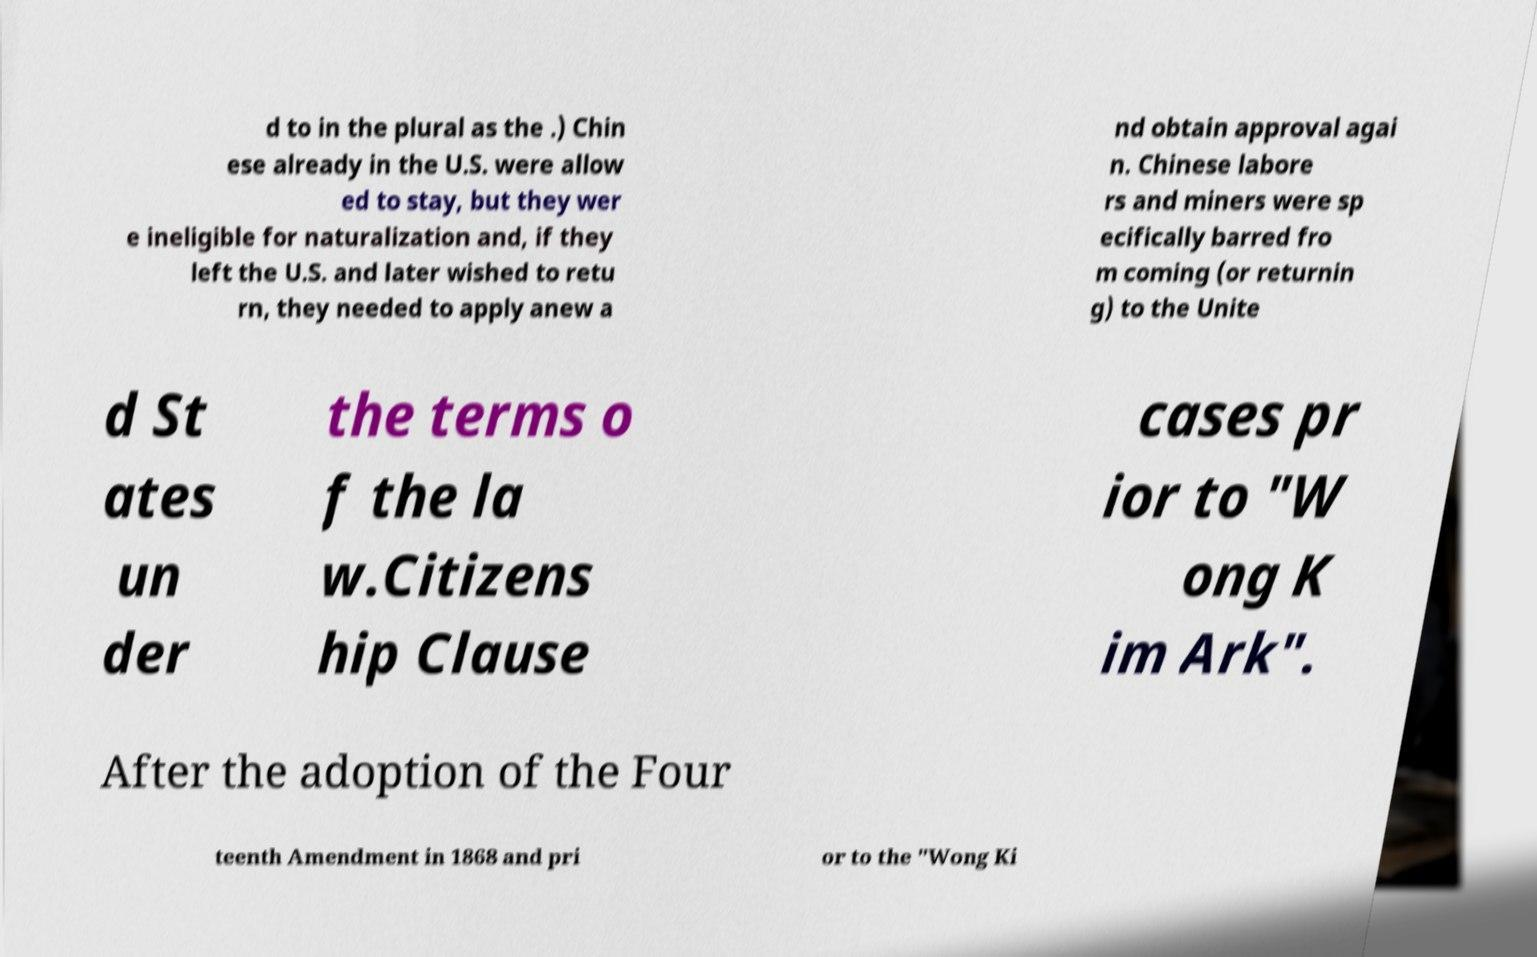Could you extract and type out the text from this image? d to in the plural as the .) Chin ese already in the U.S. were allow ed to stay, but they wer e ineligible for naturalization and, if they left the U.S. and later wished to retu rn, they needed to apply anew a nd obtain approval agai n. Chinese labore rs and miners were sp ecifically barred fro m coming (or returnin g) to the Unite d St ates un der the terms o f the la w.Citizens hip Clause cases pr ior to "W ong K im Ark". After the adoption of the Four teenth Amendment in 1868 and pri or to the "Wong Ki 